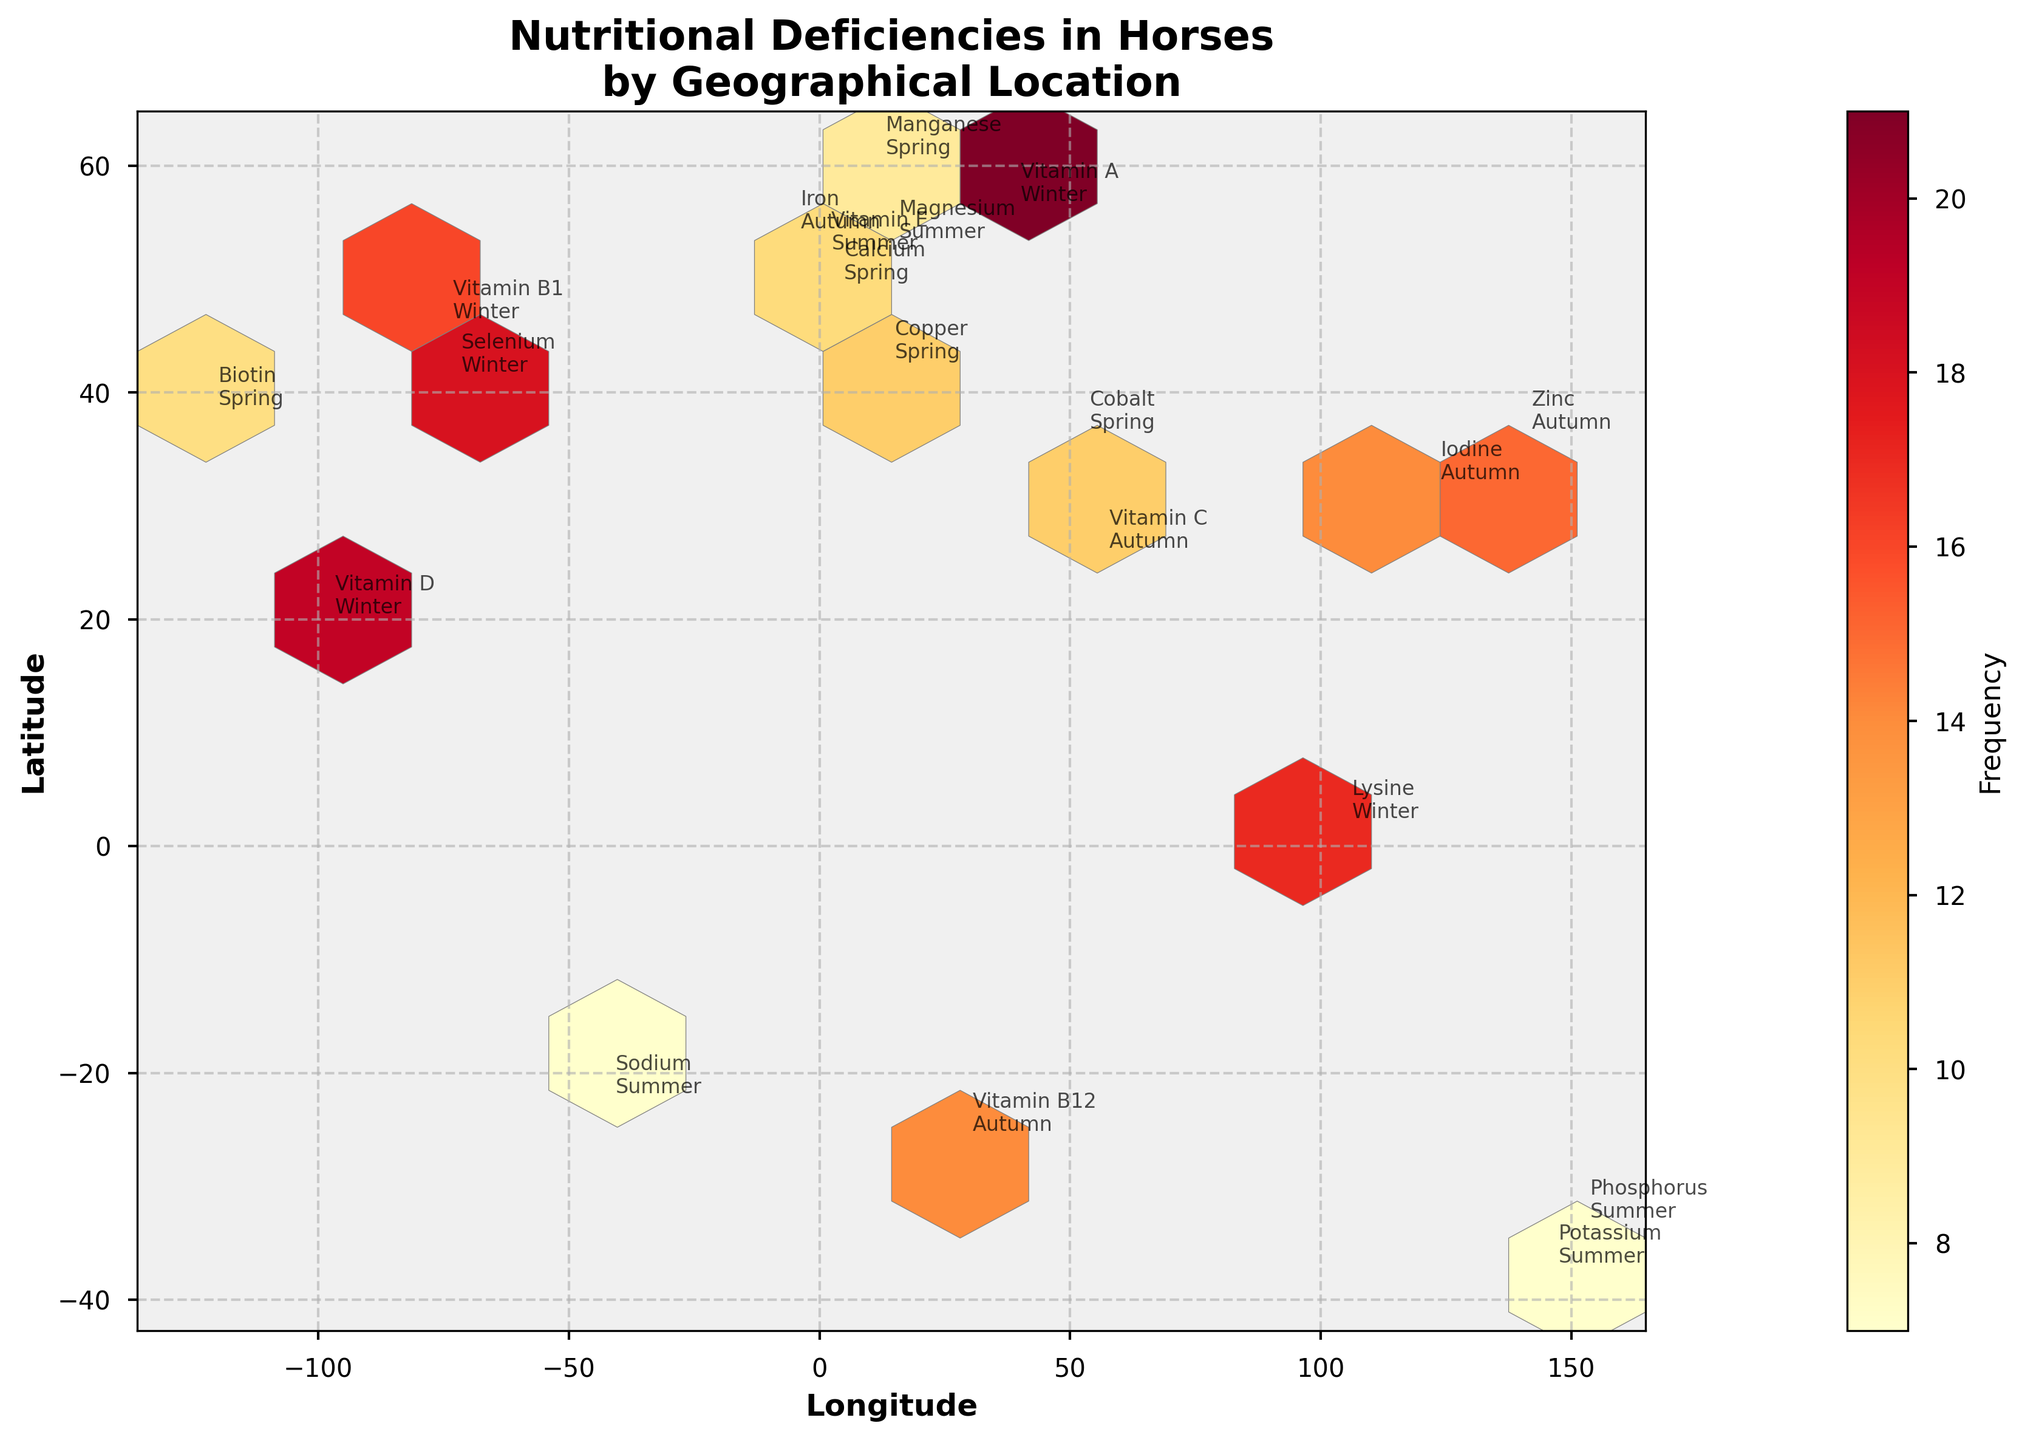What is the title of the plot? The title of the plot is always displayed prominently at the top, usually in a larger font size. In this case, it reads "Nutritional Deficiencies in Horses by Geographical Location."
Answer: Nutritional Deficiencies in Horses by Geographical Location What are the labels on the x-axis and y-axis? The labels on the axes are typically at the ends of the axes lines. In the figure, the x-axis is labeled "Longitude" and the y-axis is labeled "Latitude."
Answer: Longitude and Latitude Which location shows the highest frequency of nutritional deficiency? By observing the color intensity from the color bar, which represents frequency, the location with the darkest color indicates the highest frequency. In this case, the location at approximately 55.7558 latitude and 37.6173 longitude shows the highest frequency of 21.
Answer: 55.7558 latitude, 37.6173 longitude What nutritional deficiency is most common in winter? Looking at the labels annotated with "Winter" and comparing their frequencies, the highest frequency is at 55.7558 latitude and 37.6173 longitude with "Vitamin A" deficiency and a frequency of 21.
Answer: Vitamin A How many data points are there in total? Each data point corresponds to an entry in the dataset. Counting all the entries, we find there are 19 data points. This is also visible by counting the separate annotations on the plot.
Answer: 19 Which nutritional deficiencies occur in two different seasons, and which seasons are they? Checking the annotations for repeated nutritional deficiencies and their respective seasons, it can be determined that "Vitamin C" and "Vitamin E" do not fall into this category.
Answer: None What is the average frequency of nutritional deficiencies occurring in autumn? Find the sum of frequencies for all deficiencies in autumn: 15 (Zinc) + 14 (Iodine) + 13 (Iron) + 14 (Vitamin B12) + 12 (Vitamin C). The total is 68. Dividing by the number of entries (5), we get the average: 68/5 = 13.6.
Answer: 13.6 Which geographical location has both high and low frequencies of nutritional deficiencies? By observing the plot for any locations with repeated deficiencies and varying frequencies, it is evident that only unique frequencies are shown for each location. Therefore, there are no locations with both high and low frequencies of deficiencies.
Answer: None Which season has the lowest recorded frequency for a single nutritional deficiency, and what is that frequency? Checking the labels for the lowest frequency, it is seen that "Potassium" in summer has the lowest single frequency of 6 at approximately -37.8136 latitude and 144.9631 longitude.
Answer: Summer, 6 In which continent do we observe the highest variety of nutritional deficiencies? Observing the annotated labels geographically, Europe has the highest variety with deficiencies such as Vitamin E, Calcium, Magnesium, and Copper.
Answer: Europe 